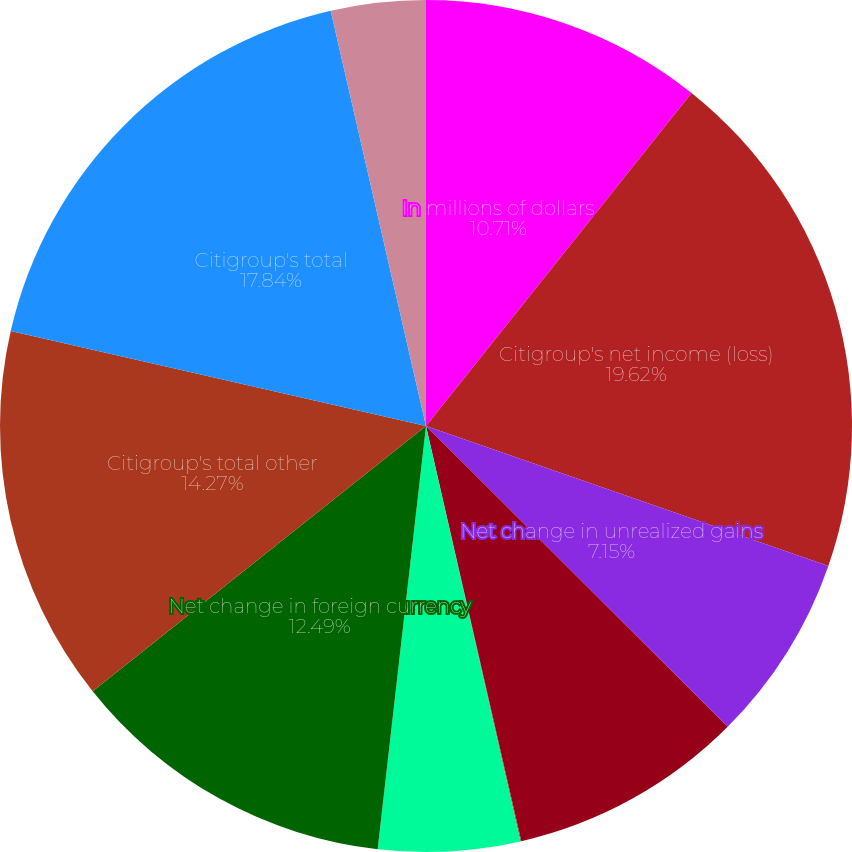Convert chart to OTSL. <chart><loc_0><loc_0><loc_500><loc_500><pie_chart><fcel>In millions of dollars<fcel>Citigroup's net income (loss)<fcel>Net change in unrealized gains<fcel>Net change in debt valuation<fcel>Net change in cash flow hedges<fcel>Benefit plans liability<fcel>Net change in foreign currency<fcel>Citigroup's total other<fcel>Citigroup's total<fcel>Add Other comprehensive income<nl><fcel>10.71%<fcel>19.61%<fcel>7.15%<fcel>8.93%<fcel>0.03%<fcel>5.37%<fcel>12.49%<fcel>14.27%<fcel>17.83%<fcel>3.59%<nl></chart> 